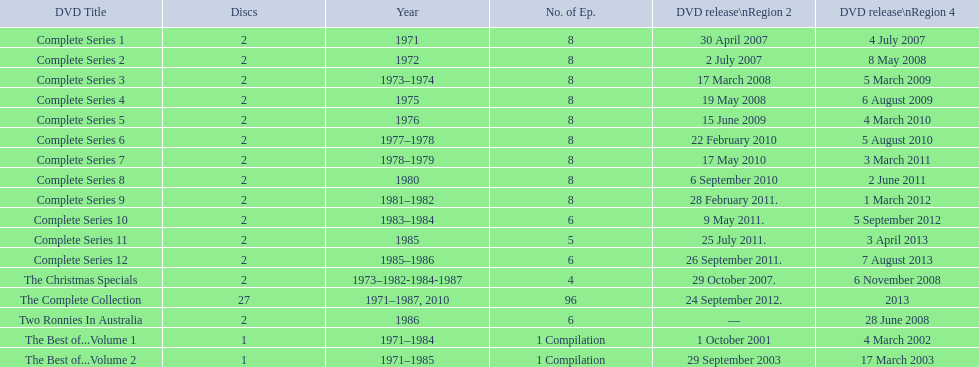What follows directly after the full series 11? Complete Series 12. Help me parse the entirety of this table. {'header': ['DVD Title', 'Discs', 'Year', 'No. of Ep.', 'DVD release\\nRegion 2', 'DVD release\\nRegion 4'], 'rows': [['Complete Series 1', '2', '1971', '8', '30 April 2007', '4 July 2007'], ['Complete Series 2', '2', '1972', '8', '2 July 2007', '8 May 2008'], ['Complete Series 3', '2', '1973–1974', '8', '17 March 2008', '5 March 2009'], ['Complete Series 4', '2', '1975', '8', '19 May 2008', '6 August 2009'], ['Complete Series 5', '2', '1976', '8', '15 June 2009', '4 March 2010'], ['Complete Series 6', '2', '1977–1978', '8', '22 February 2010', '5 August 2010'], ['Complete Series 7', '2', '1978–1979', '8', '17 May 2010', '3 March 2011'], ['Complete Series 8', '2', '1980', '8', '6 September 2010', '2 June 2011'], ['Complete Series 9', '2', '1981–1982', '8', '28 February 2011.', '1 March 2012'], ['Complete Series 10', '2', '1983–1984', '6', '9 May 2011.', '5 September 2012'], ['Complete Series 11', '2', '1985', '5', '25 July 2011.', '3 April 2013'], ['Complete Series 12', '2', '1985–1986', '6', '26 September 2011.', '7 August 2013'], ['The Christmas Specials', '2', '1973–1982-1984-1987', '4', '29 October 2007.', '6 November 2008'], ['The Complete Collection', '27', '1971–1987, 2010', '96', '24 September 2012.', '2013'], ['Two Ronnies In Australia', '2', '1986', '6', '—', '28 June 2008'], ['The Best of...Volume 1', '1', '1971–1984', '1 Compilation', '1 October 2001', '4 March 2002'], ['The Best of...Volume 2', '1', '1971–1985', '1 Compilation', '29 September 2003', '17 March 2003']]} 